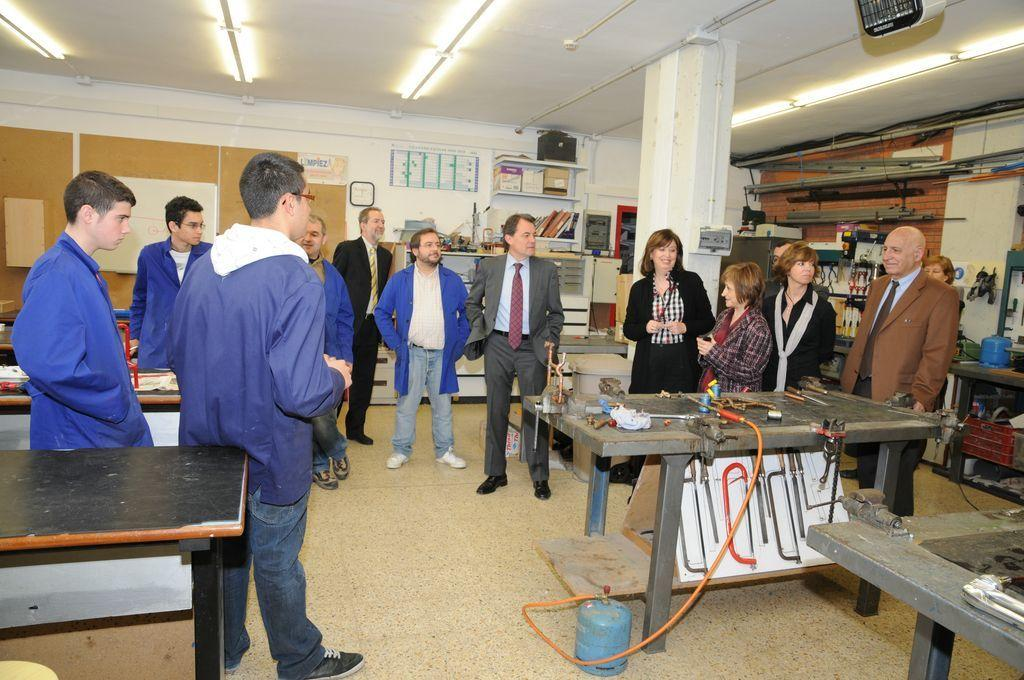How many people are in the image? There is a group of people in the image. What are the people in the image doing? The people are standing. What is on the table in the image? There are tools and hardware parts on the table. What can be seen near the table in the image? There is a gas cylinder in the image. What type of dust can be seen on the brother's car in the image? There is no brother or car present in the image, so there is no dust to be observed. 